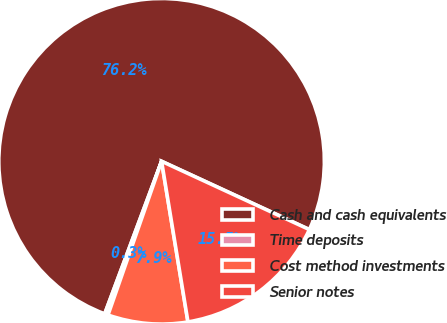<chart> <loc_0><loc_0><loc_500><loc_500><pie_chart><fcel>Cash and cash equivalents<fcel>Time deposits<fcel>Cost method investments<fcel>Senior notes<nl><fcel>76.21%<fcel>0.34%<fcel>7.93%<fcel>15.52%<nl></chart> 